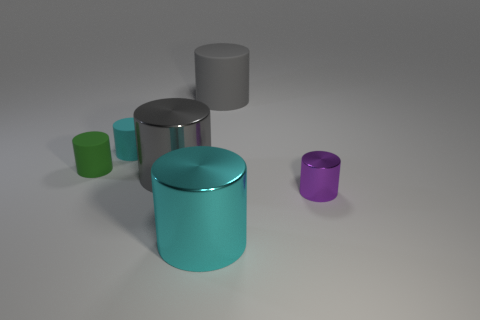What is the material of the small cyan cylinder? While I can't confirm the material with absolute certainty from the image alone, the small cyan cylinder appears to have a matte surface that might resemble plastic or painted metal, common materials for everyday objects. 